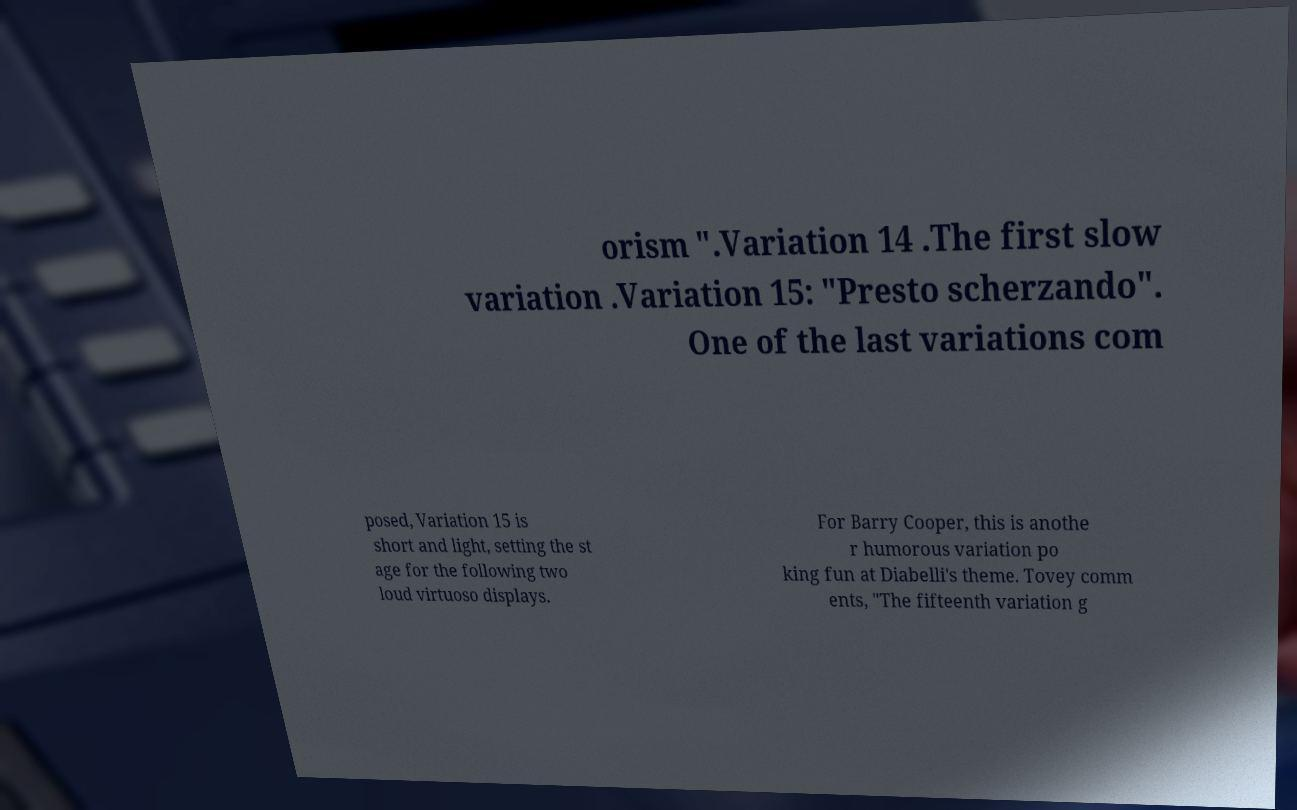Can you accurately transcribe the text from the provided image for me? orism ".Variation 14 .The first slow variation .Variation 15: "Presto scherzando". One of the last variations com posed, Variation 15 is short and light, setting the st age for the following two loud virtuoso displays. For Barry Cooper, this is anothe r humorous variation po king fun at Diabelli's theme. Tovey comm ents, "The fifteenth variation g 